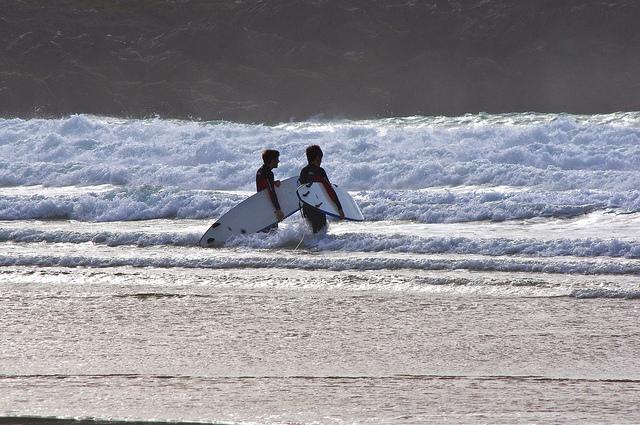What color are the surfboards?
Keep it brief. White. Are the waves high enough for surfing?
Write a very short answer. Yes. Are they surfing?
Give a very brief answer. Yes. 